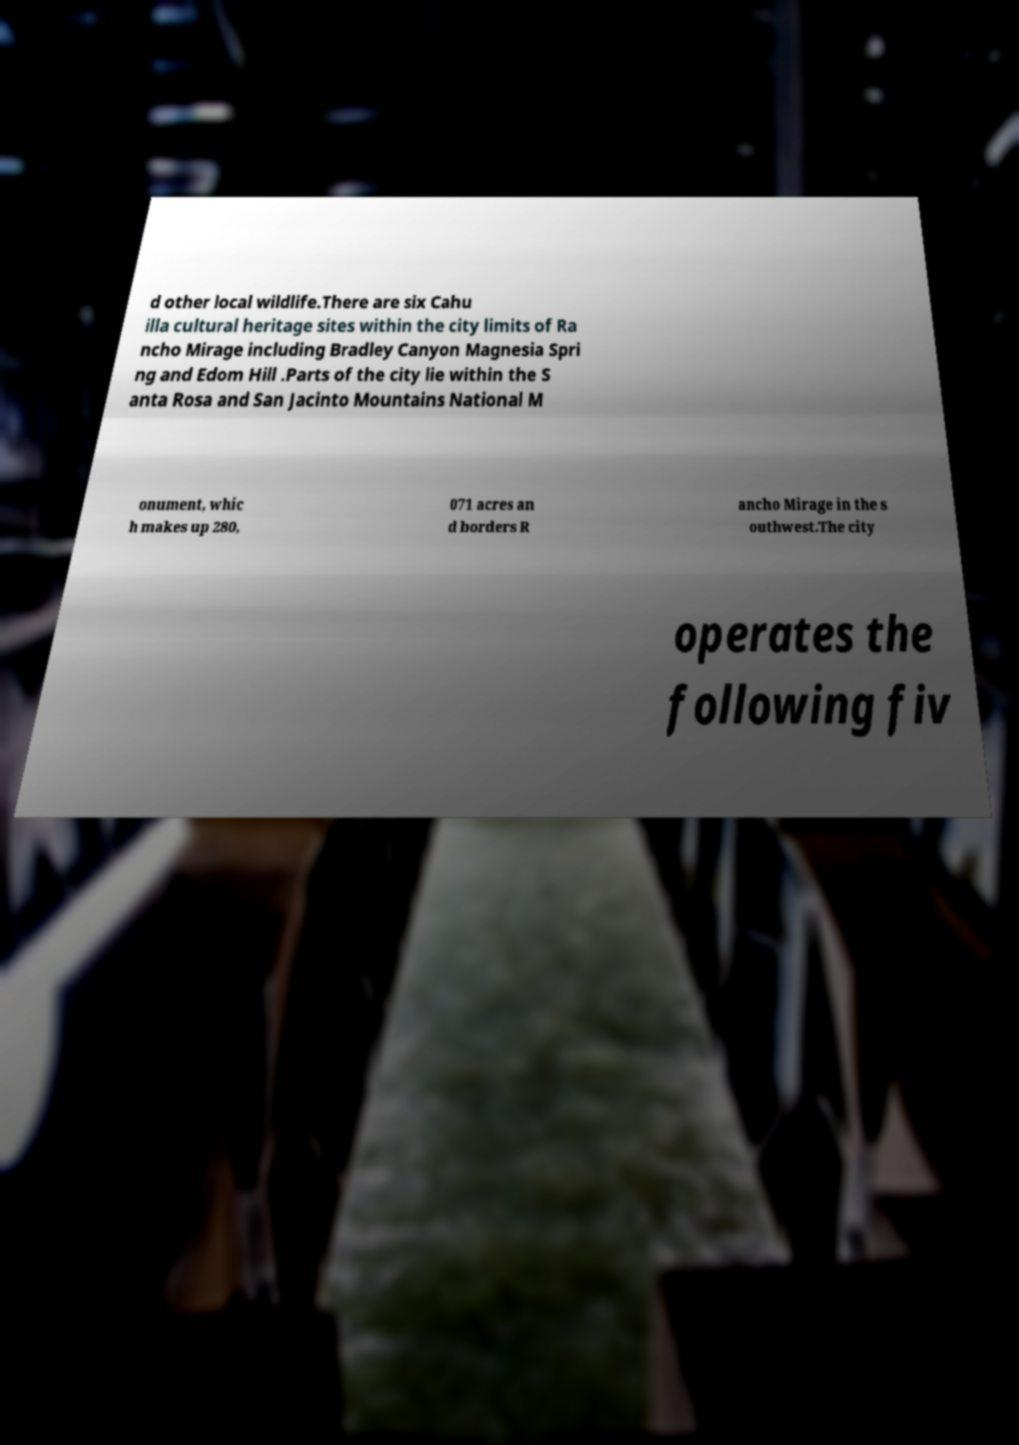Can you accurately transcribe the text from the provided image for me? d other local wildlife.There are six Cahu illa cultural heritage sites within the city limits of Ra ncho Mirage including Bradley Canyon Magnesia Spri ng and Edom Hill .Parts of the city lie within the S anta Rosa and San Jacinto Mountains National M onument, whic h makes up 280, 071 acres an d borders R ancho Mirage in the s outhwest.The city operates the following fiv 